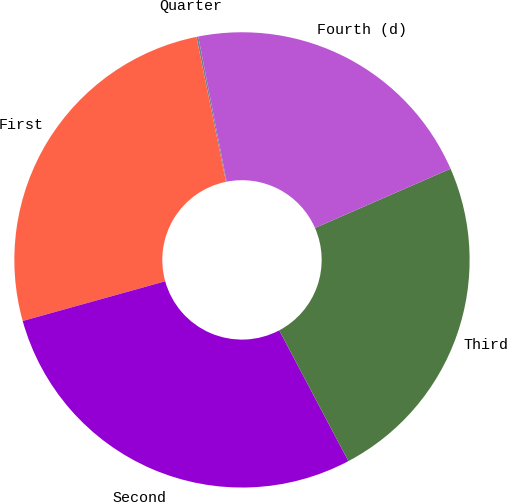<chart> <loc_0><loc_0><loc_500><loc_500><pie_chart><fcel>Quarter<fcel>First<fcel>Second<fcel>Third<fcel>Fourth (d)<nl><fcel>0.13%<fcel>26.12%<fcel>28.42%<fcel>23.82%<fcel>21.52%<nl></chart> 